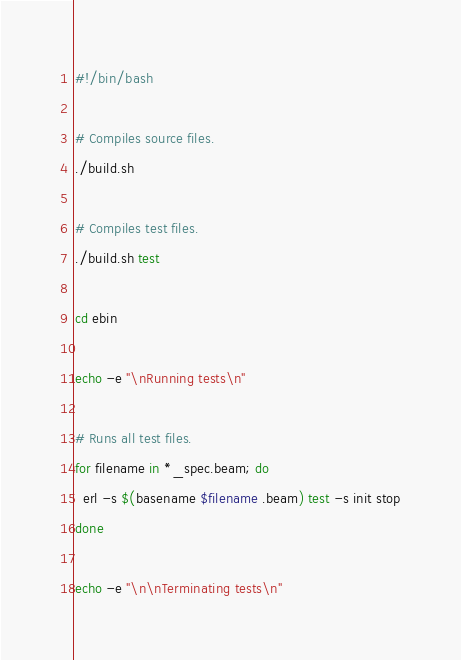Convert code to text. <code><loc_0><loc_0><loc_500><loc_500><_Bash_>#!/bin/bash

# Compiles source files.
./build.sh

# Compiles test files.
./build.sh test

cd ebin

echo -e "\nRunning tests\n"

# Runs all test files.
for filename in *_spec.beam; do
  erl -s $(basename $filename .beam) test -s init stop
done

echo -e "\n\nTerminating tests\n"
</code> 